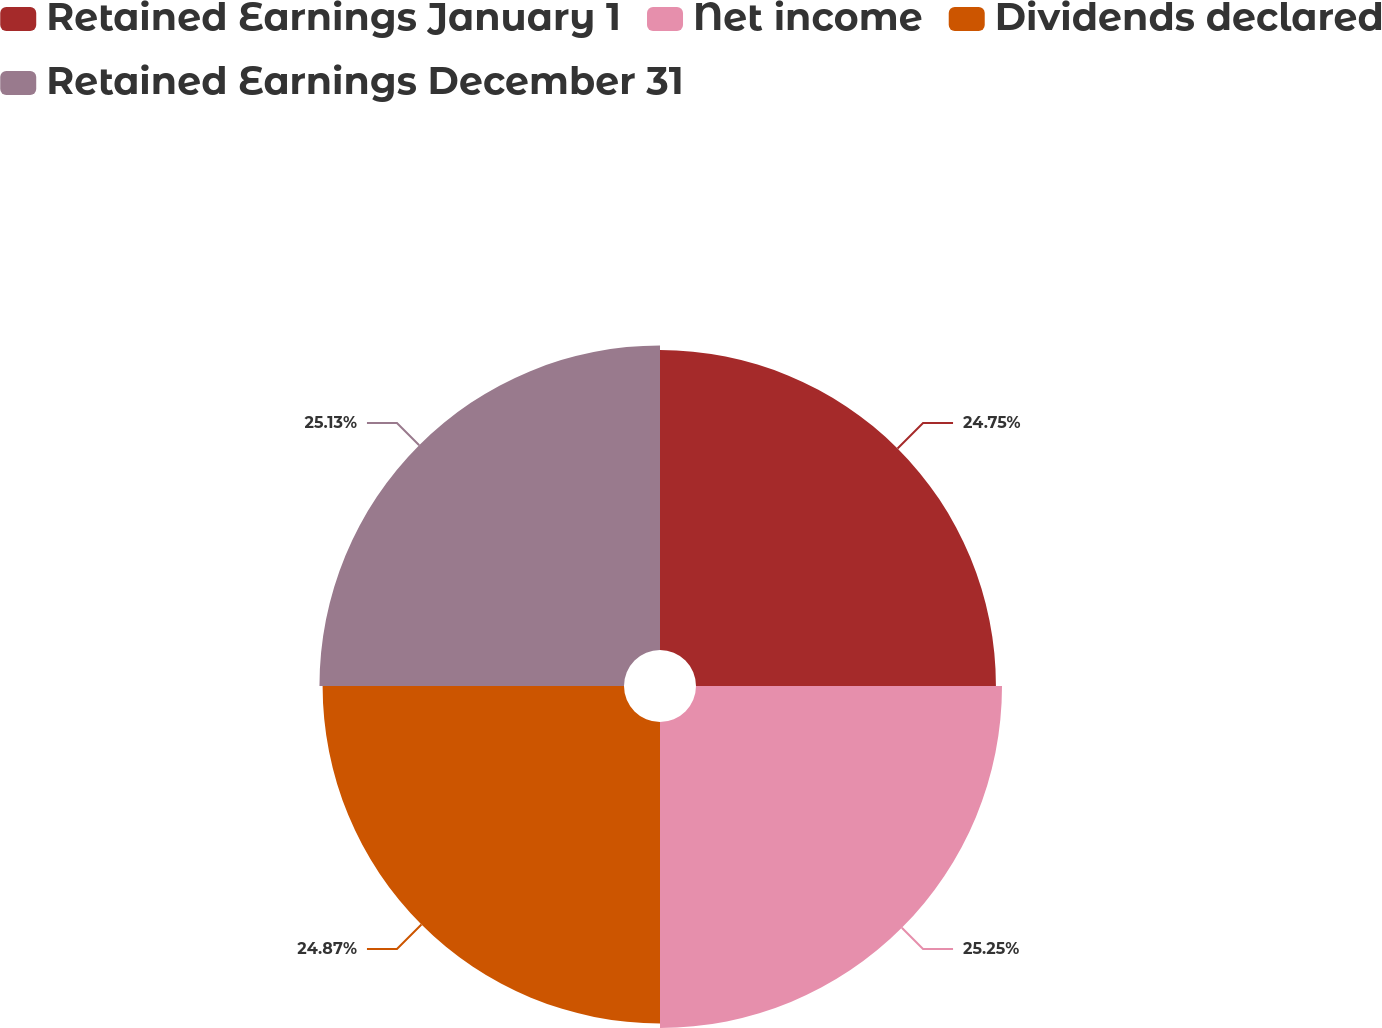Convert chart. <chart><loc_0><loc_0><loc_500><loc_500><pie_chart><fcel>Retained Earnings January 1<fcel>Net income<fcel>Dividends declared<fcel>Retained Earnings December 31<nl><fcel>24.75%<fcel>25.25%<fcel>24.87%<fcel>25.13%<nl></chart> 